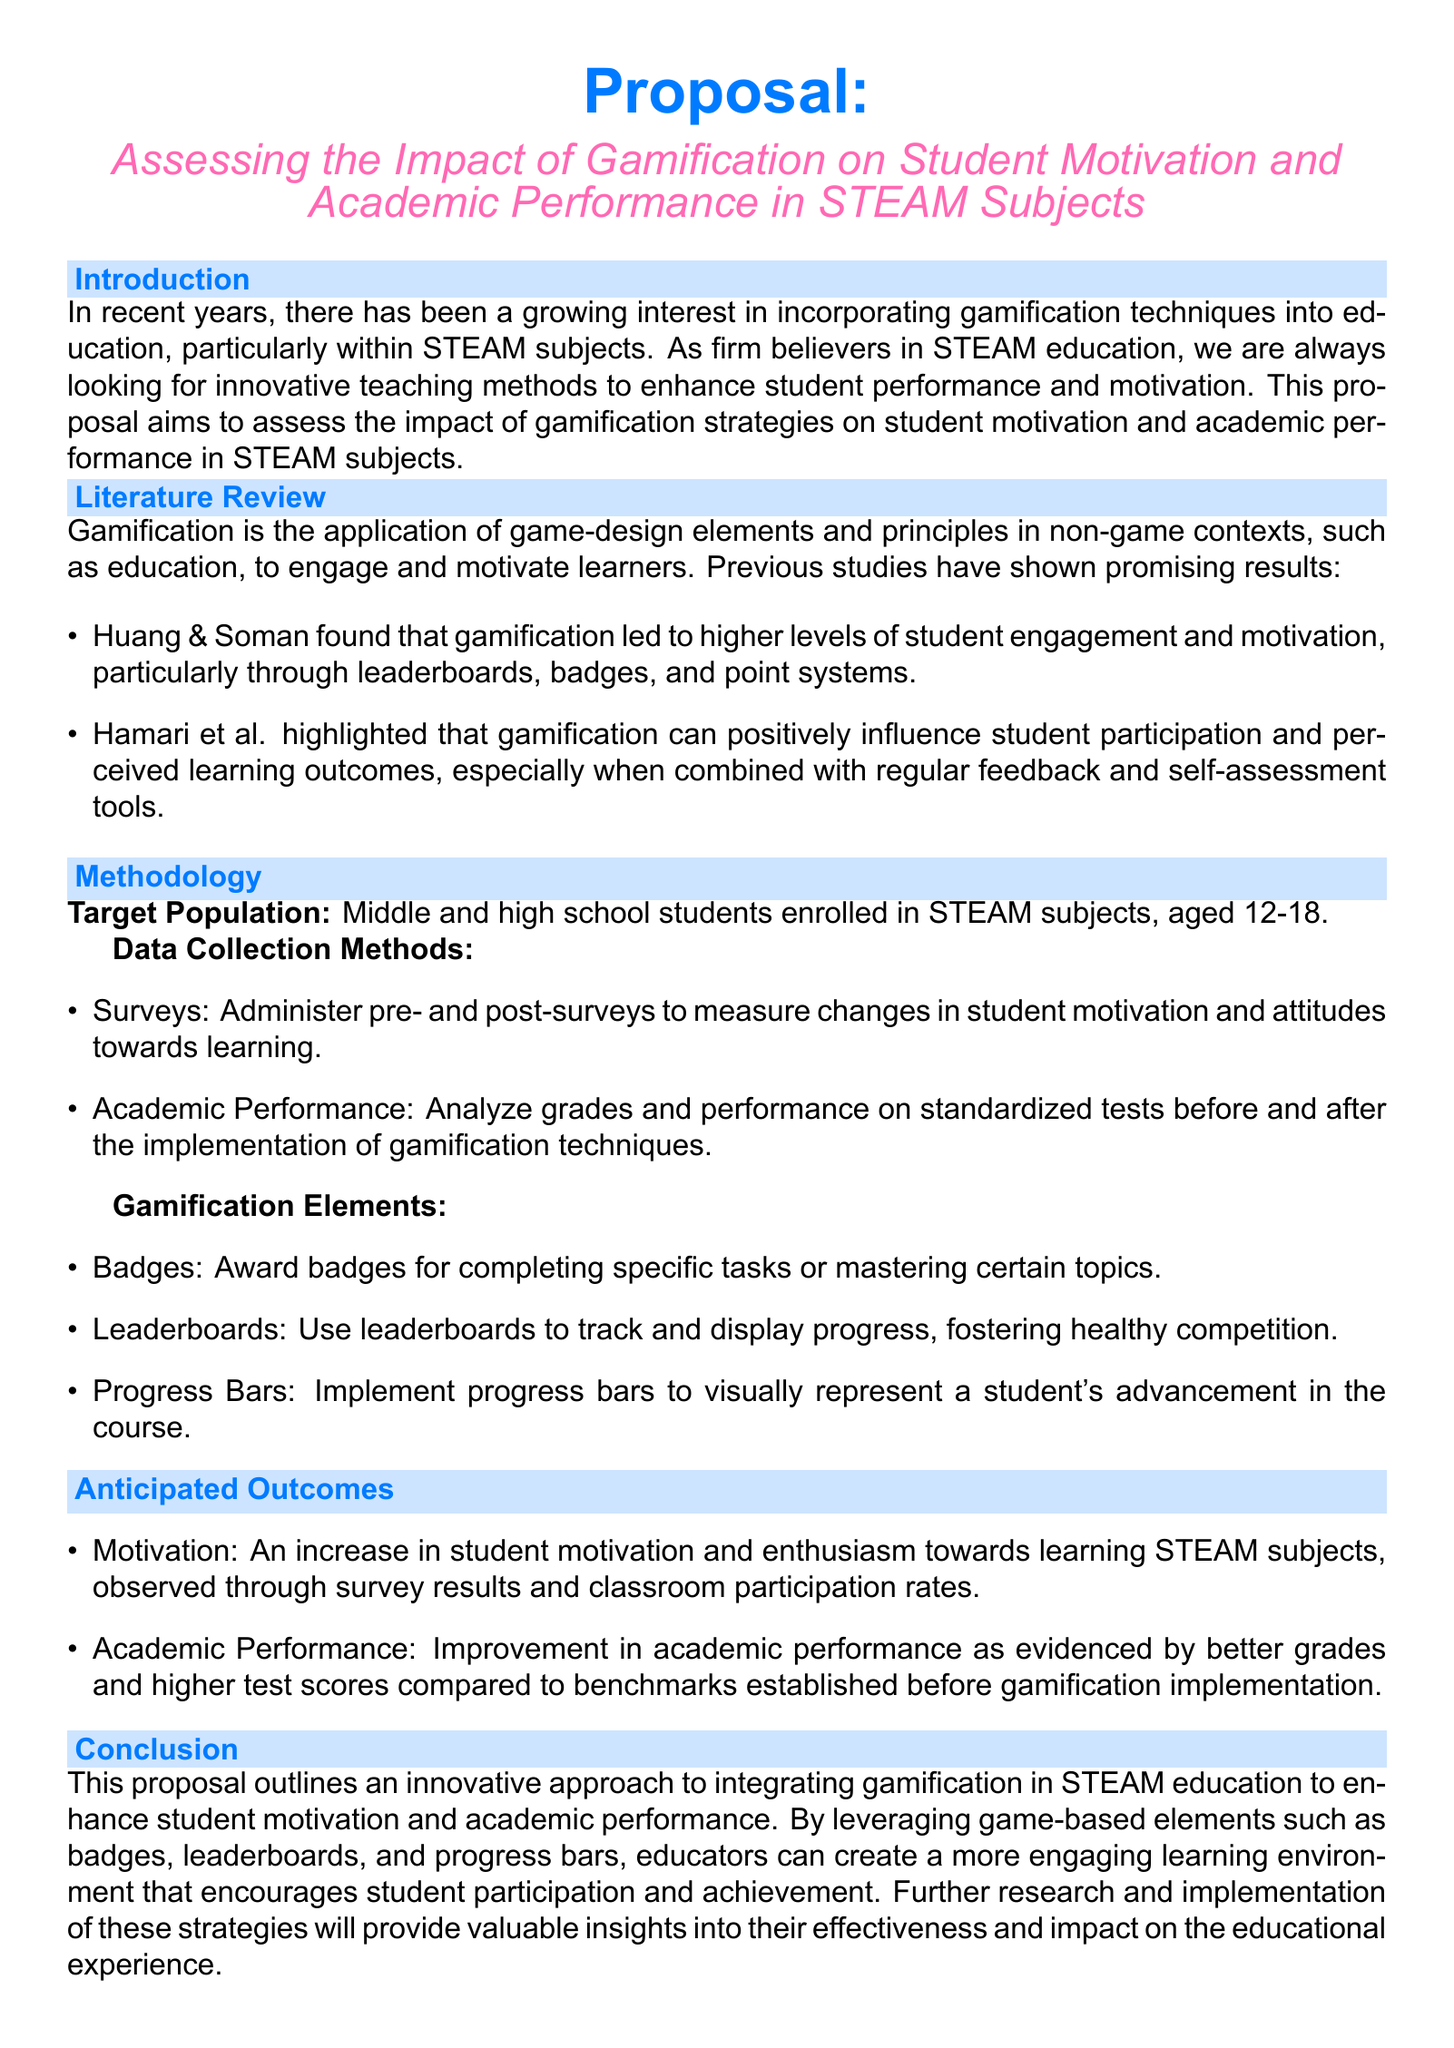What is the focus of the proposal? The proposal focuses on assessing the impact of gamification on student motivation and academic performance in STEAM subjects.
Answer: Impact of gamification on student motivation and academic performance in STEAM subjects What age group is targeted in the study? The target population includes middle and high school students, specifically aged 12-18.
Answer: Aged 12-18 What are two gamification elements mentioned? The document lists badges, leaderboards, and progress bars as gamification elements, mentioning any two of them qualifies.
Answer: Badges, Leaderboards Who conducted previous research on gamification mentioned in the document? Huang & Soman are mentioned as conducting research that found positive outcomes from gamification.
Answer: Huang & Soman What is a method for measuring academic performance stated in the proposal? Academic performance will be measured by analyzing grades and performance on standardized tests before and after gamification.
Answer: Analyzing grades and standardized tests What do the anticipated outcomes include regarding motivation? The anticipated outcome mentions an increase in student motivation and enthusiasm towards learning.
Answer: An increase in student motivation and enthusiasm Which research finding is highlighted by Hamari et al.? Hamari et al. highlighted that gamification positively influences student participation and perceived learning outcomes.
Answer: Positive influence on student participation and perceived learning outcomes What are the two main anticipated outcomes of implementing gamification? The two main anticipated outcomes are increased motivation and improved academic performance.
Answer: Increased motivation and improved academic performance 